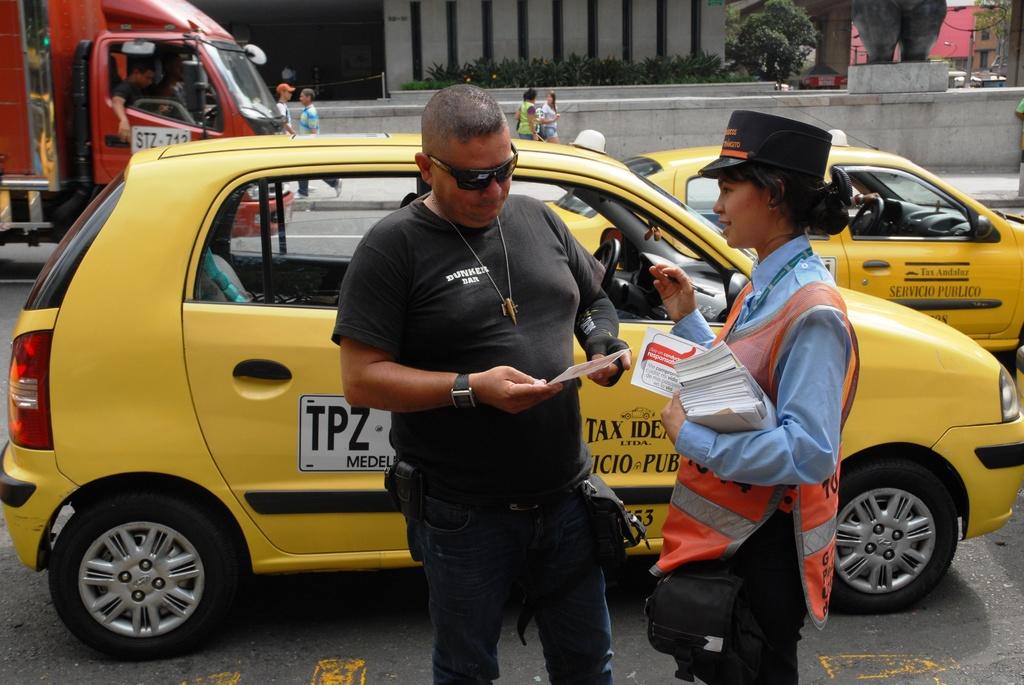What three letters are visible on the car to the left of the man?
Your response must be concise. Tpz. 